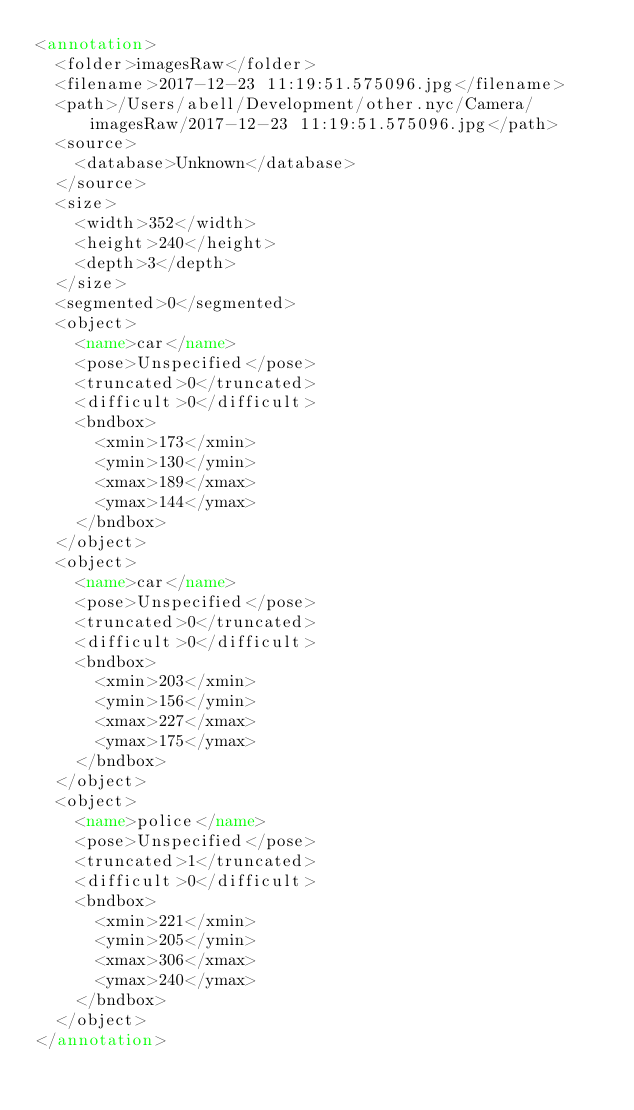<code> <loc_0><loc_0><loc_500><loc_500><_XML_><annotation>
	<folder>imagesRaw</folder>
	<filename>2017-12-23 11:19:51.575096.jpg</filename>
	<path>/Users/abell/Development/other.nyc/Camera/imagesRaw/2017-12-23 11:19:51.575096.jpg</path>
	<source>
		<database>Unknown</database>
	</source>
	<size>
		<width>352</width>
		<height>240</height>
		<depth>3</depth>
	</size>
	<segmented>0</segmented>
	<object>
		<name>car</name>
		<pose>Unspecified</pose>
		<truncated>0</truncated>
		<difficult>0</difficult>
		<bndbox>
			<xmin>173</xmin>
			<ymin>130</ymin>
			<xmax>189</xmax>
			<ymax>144</ymax>
		</bndbox>
	</object>
	<object>
		<name>car</name>
		<pose>Unspecified</pose>
		<truncated>0</truncated>
		<difficult>0</difficult>
		<bndbox>
			<xmin>203</xmin>
			<ymin>156</ymin>
			<xmax>227</xmax>
			<ymax>175</ymax>
		</bndbox>
	</object>
	<object>
		<name>police</name>
		<pose>Unspecified</pose>
		<truncated>1</truncated>
		<difficult>0</difficult>
		<bndbox>
			<xmin>221</xmin>
			<ymin>205</ymin>
			<xmax>306</xmax>
			<ymax>240</ymax>
		</bndbox>
	</object>
</annotation>
</code> 